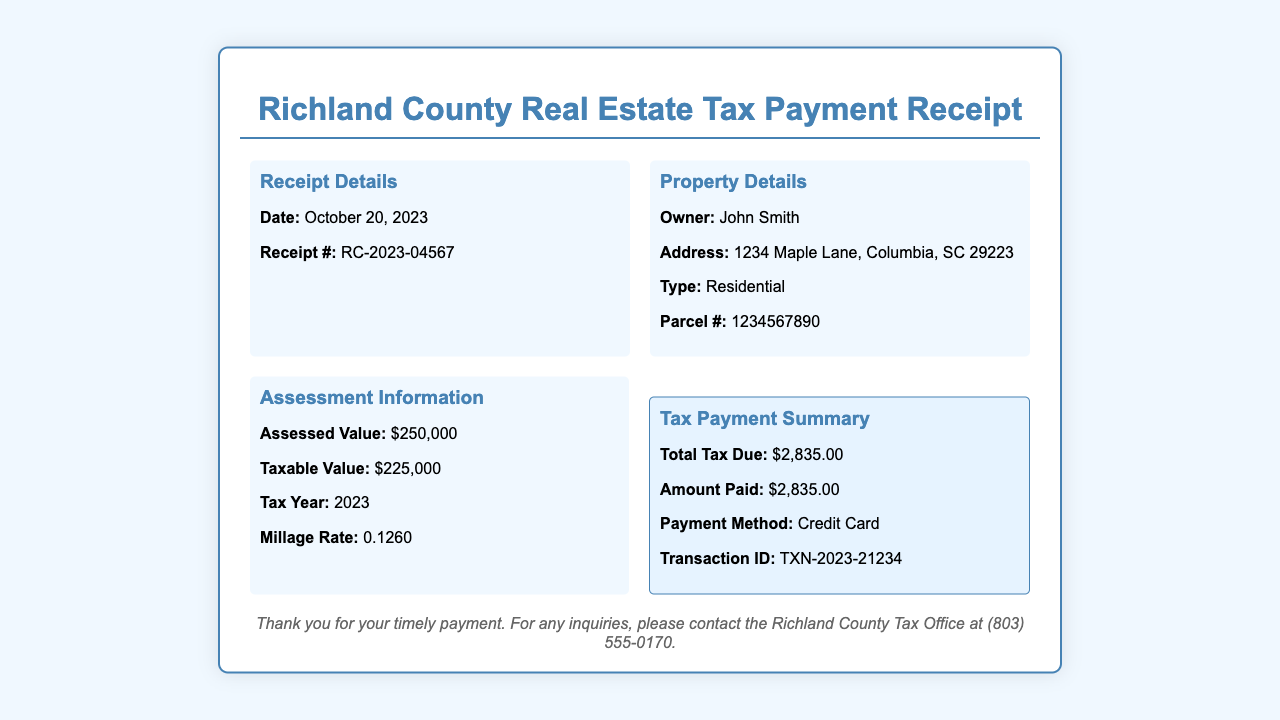What is the date of the receipt? The date of the receipt is clearly stated in the receipt details section.
Answer: October 20, 2023 What is the receipt number? The receipt number is provided in the receipt details section for reference.
Answer: RC-2023-04567 Who is the property owner? The property owner’s name is mentioned in the property details section of the document.
Answer: John Smith What is the assessed value of the property? The assessed value is listed under the assessment information section, highlighting the property's worth.
Answer: $250,000 What is the total tax due? The total tax due amount is provided in the payment summary section of the receipt.
Answer: $2,835.00 What payment method was used? The payment method is outlined in the payment summary section of the receipt for clarity on how the payment was processed.
Answer: Credit Card What is the taxable value of the property? The taxable value is included in the assessment information and indicates the value used for tax calculations.
Answer: $225,000 What is the millage rate? The millage rate is specified in the assessment information section and is important for understanding property taxation.
Answer: 0.1260 What is the transaction ID? The transaction ID is provided in the payment summary section as a reference for the payment made.
Answer: TXN-2023-21234 